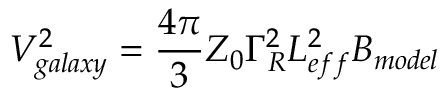<formula> <loc_0><loc_0><loc_500><loc_500>V _ { g a l a x y } ^ { 2 } = \frac { 4 \pi } { 3 } Z _ { 0 } \Gamma _ { R } ^ { 2 } L _ { e f f } ^ { 2 } B _ { m o d e l }</formula> 